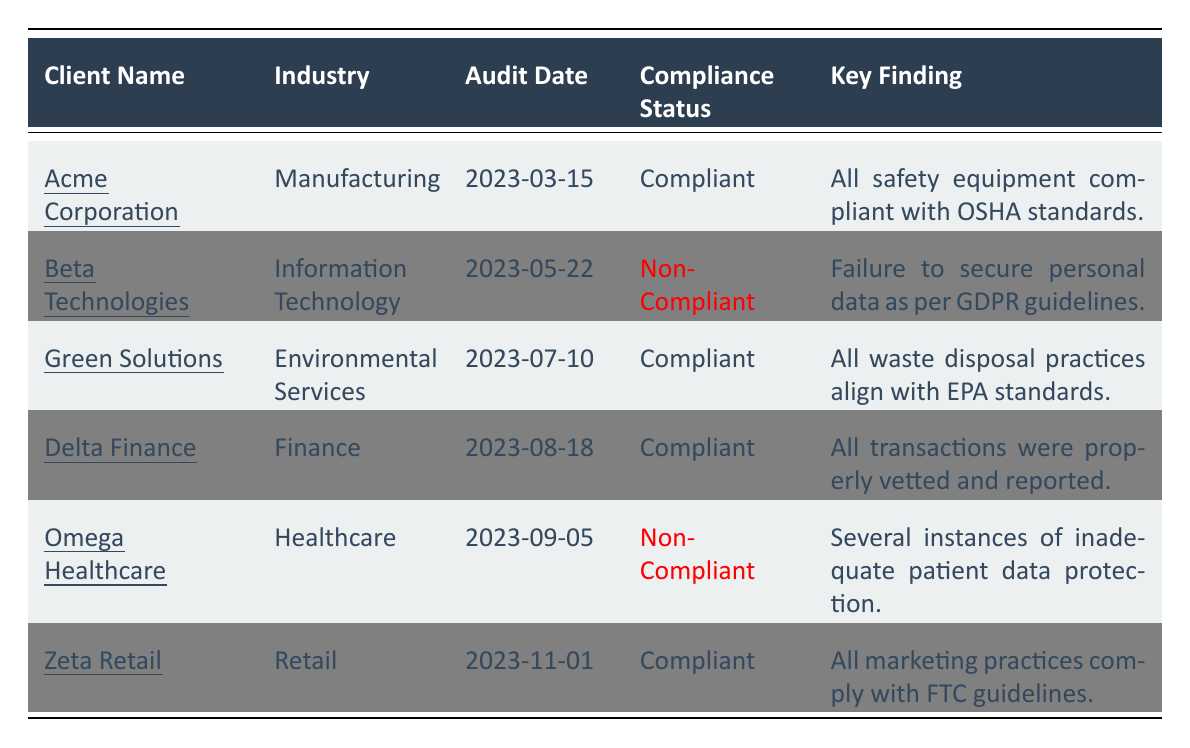What is the compliance status of Acme Corporation? The table lists the compliance status of Acme Corporation as "Compliant." This is identified in the segment where Acme Corporation's details are shown.
Answer: Compliant How many clients were found to be non-compliant in 2023? The table shows two clients, Beta Technologies and Omega Healthcare, marked as "Non-Compliant" in the compliance status column. This is a direct count of occurrences.
Answer: 2 What was the audit date for Green Solutions? The table indicates that the audit date for Green Solutions is "2023-07-10." This date is displayed in the corresponding row for Green Solutions.
Answer: 2023-07-10 Which category had a critical finding for Beta Technologies? According to the table, the category with a critical finding for Beta Technologies is "Data Privacy," where it mentions the failure to secure personal data as per GDPR guidelines.
Answer: Data Privacy What is the severity of the findings for Omega Healthcare? The findings for Omega Healthcare are listed as "High" severity, which indicates the seriousness of the non-compliance reported. This information is visible in the related findings row.
Answer: High Which client had the earliest audit date and what was their compliance status? Acme Corporation had the earliest audit date of "2023-03-15" and their compliance status is "Compliant." This is drawn from comparing the audit dates listed in the table.
Answer: Acme Corporation, Compliant Did any of the compliant clients have findings related to safety regulations? Yes, Acme Corporation, which is compliant, had findings in the safety regulations category, confirming the adherence to OSHA standards with a low severity. This is verified by looking at the relevant row.
Answer: Yes What recommendation was given to Delta Finance? The recommendation for Delta Finance is to continue current compliance practices and conduct periodic reviews, which is stated in the corresponding row in the table.
Answer: Continue current compliance practices and conduct periodic reviews Which industry did Zeta Retail belong to? Zeta Retail is listed under the "Retail" industry in the table. This is straightforwardly determined from the industry column associated with Zeta Retail's entry.
Answer: Retail What was the key finding for the client with the latest audit date? Zeta Retail, audited on "2023-11-01," had a key finding that all marketing practices comply with FTC guidelines. This can be confirmed from the latest row in the table.
Answer: All marketing practices comply with FTC guidelines 